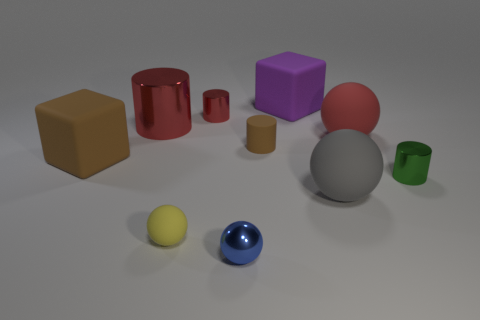Can you describe the texture of the objects in the foreground? Certainly! The yellow sphere in the foreground has a smooth, matte finish, suggesting a soft or non-reflective texture, while the blue sphere has a glossy, reflective surface indicating a hard, smooth texture. 